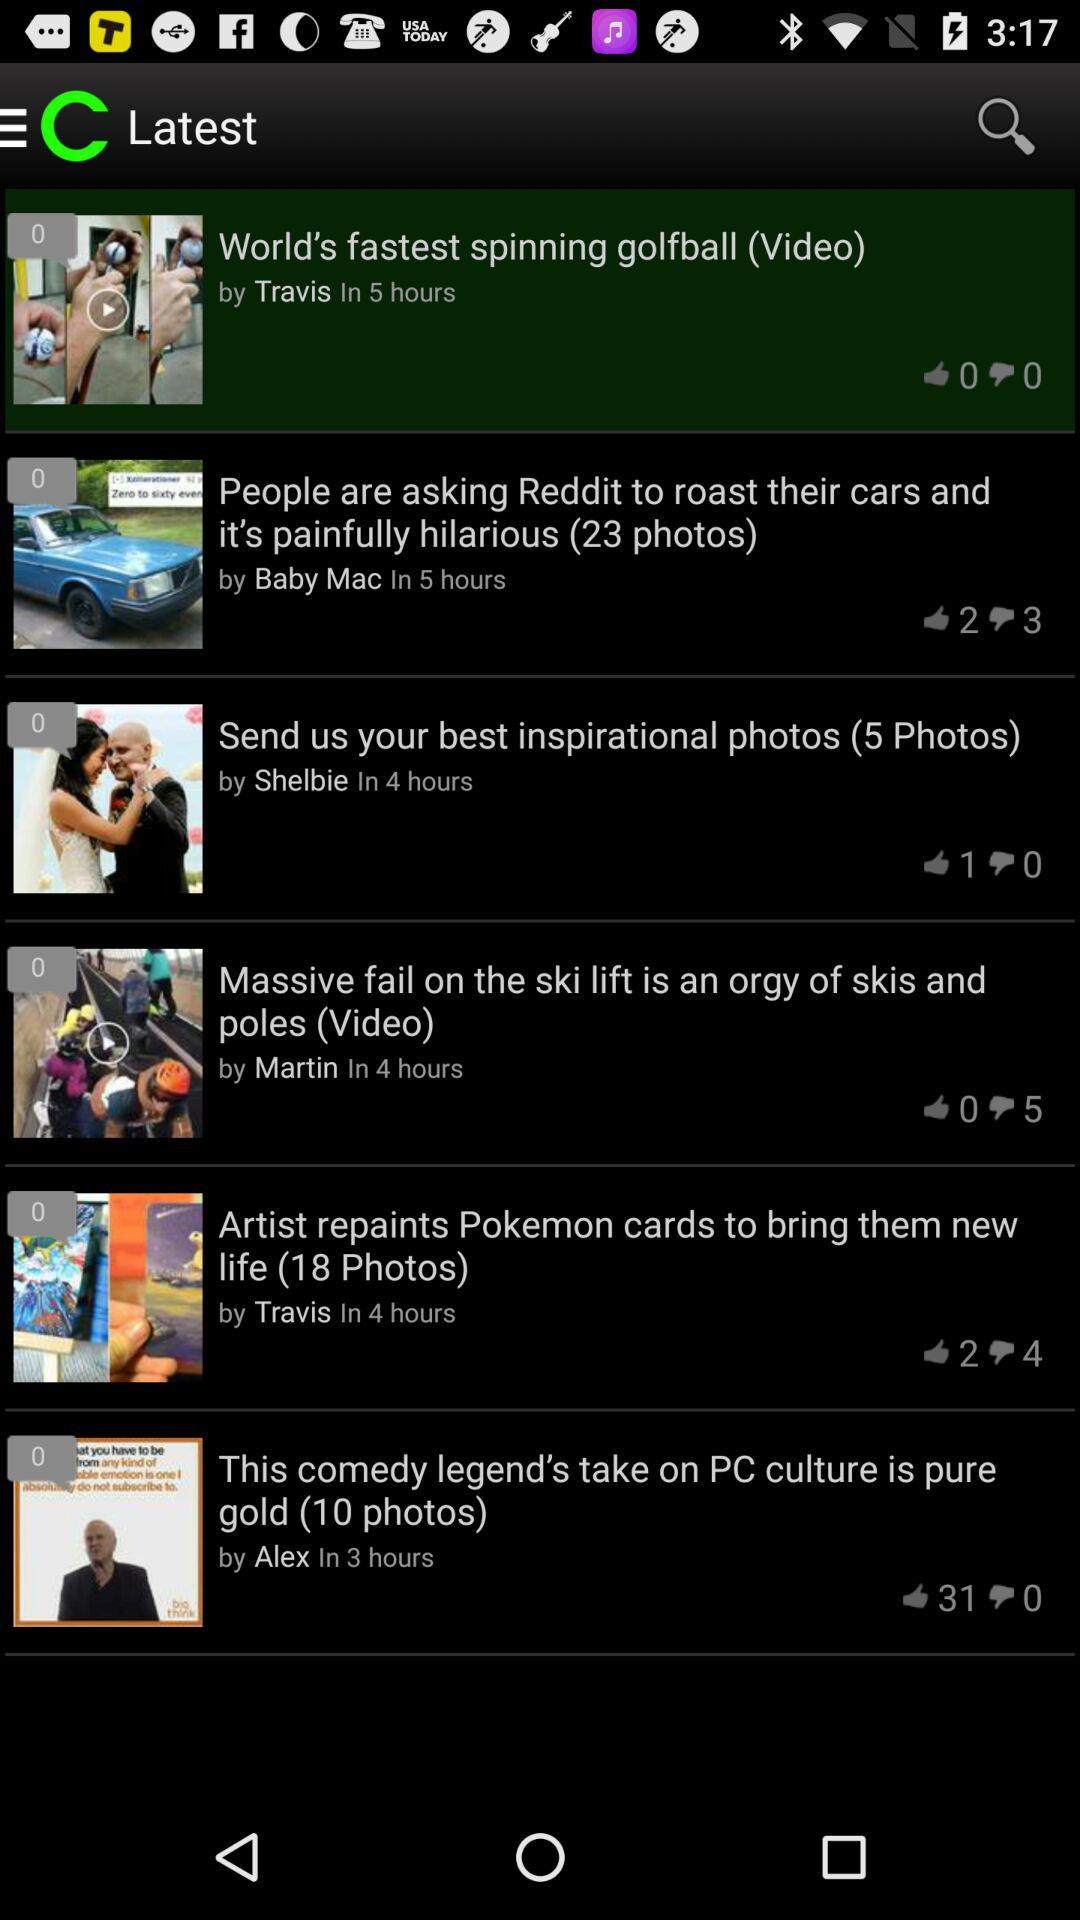How many dislikes are there of the "World's fastest spinning golfball" video? There are 0 dislikes of the "World's fastest spinning golfball" video. 